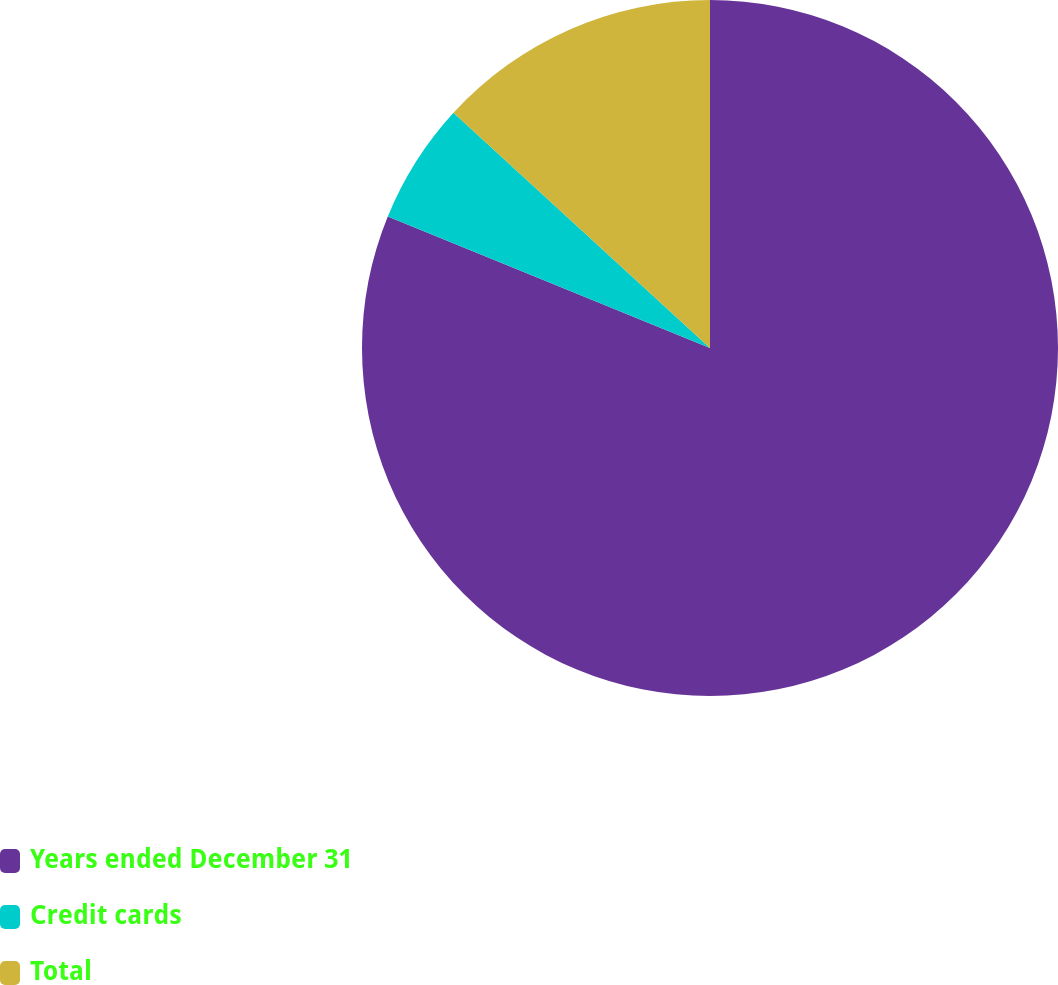Convert chart. <chart><loc_0><loc_0><loc_500><loc_500><pie_chart><fcel>Years ended December 31<fcel>Credit cards<fcel>Total<nl><fcel>81.16%<fcel>5.64%<fcel>13.19%<nl></chart> 